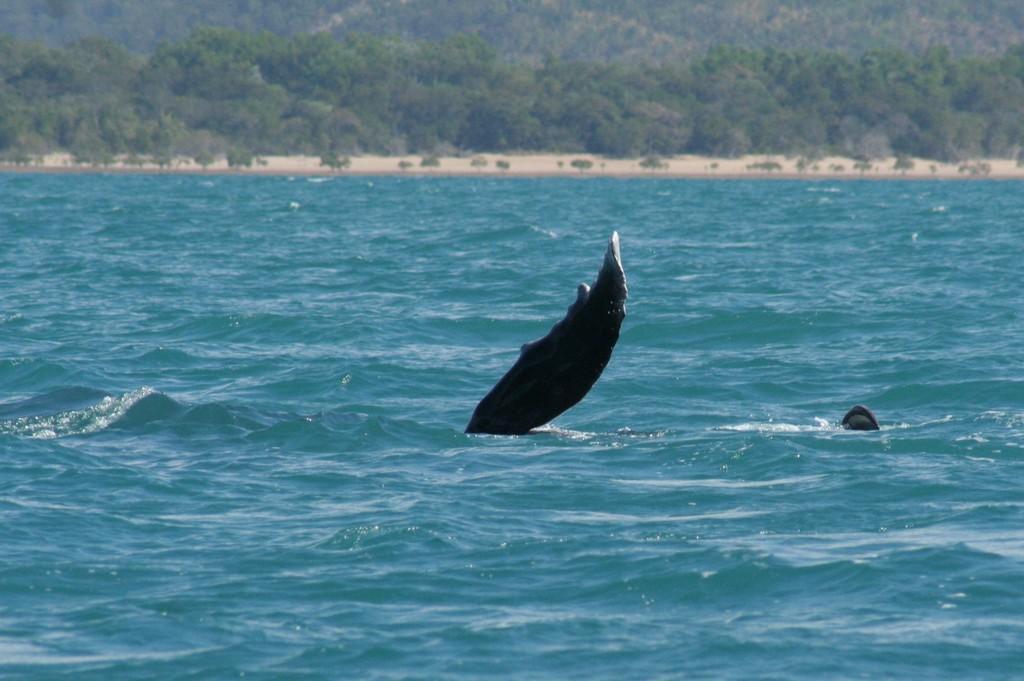How would you summarize this image in a sentence or two? In this image I can see an aquatic animal in the water. In the background, I can see the trees. 